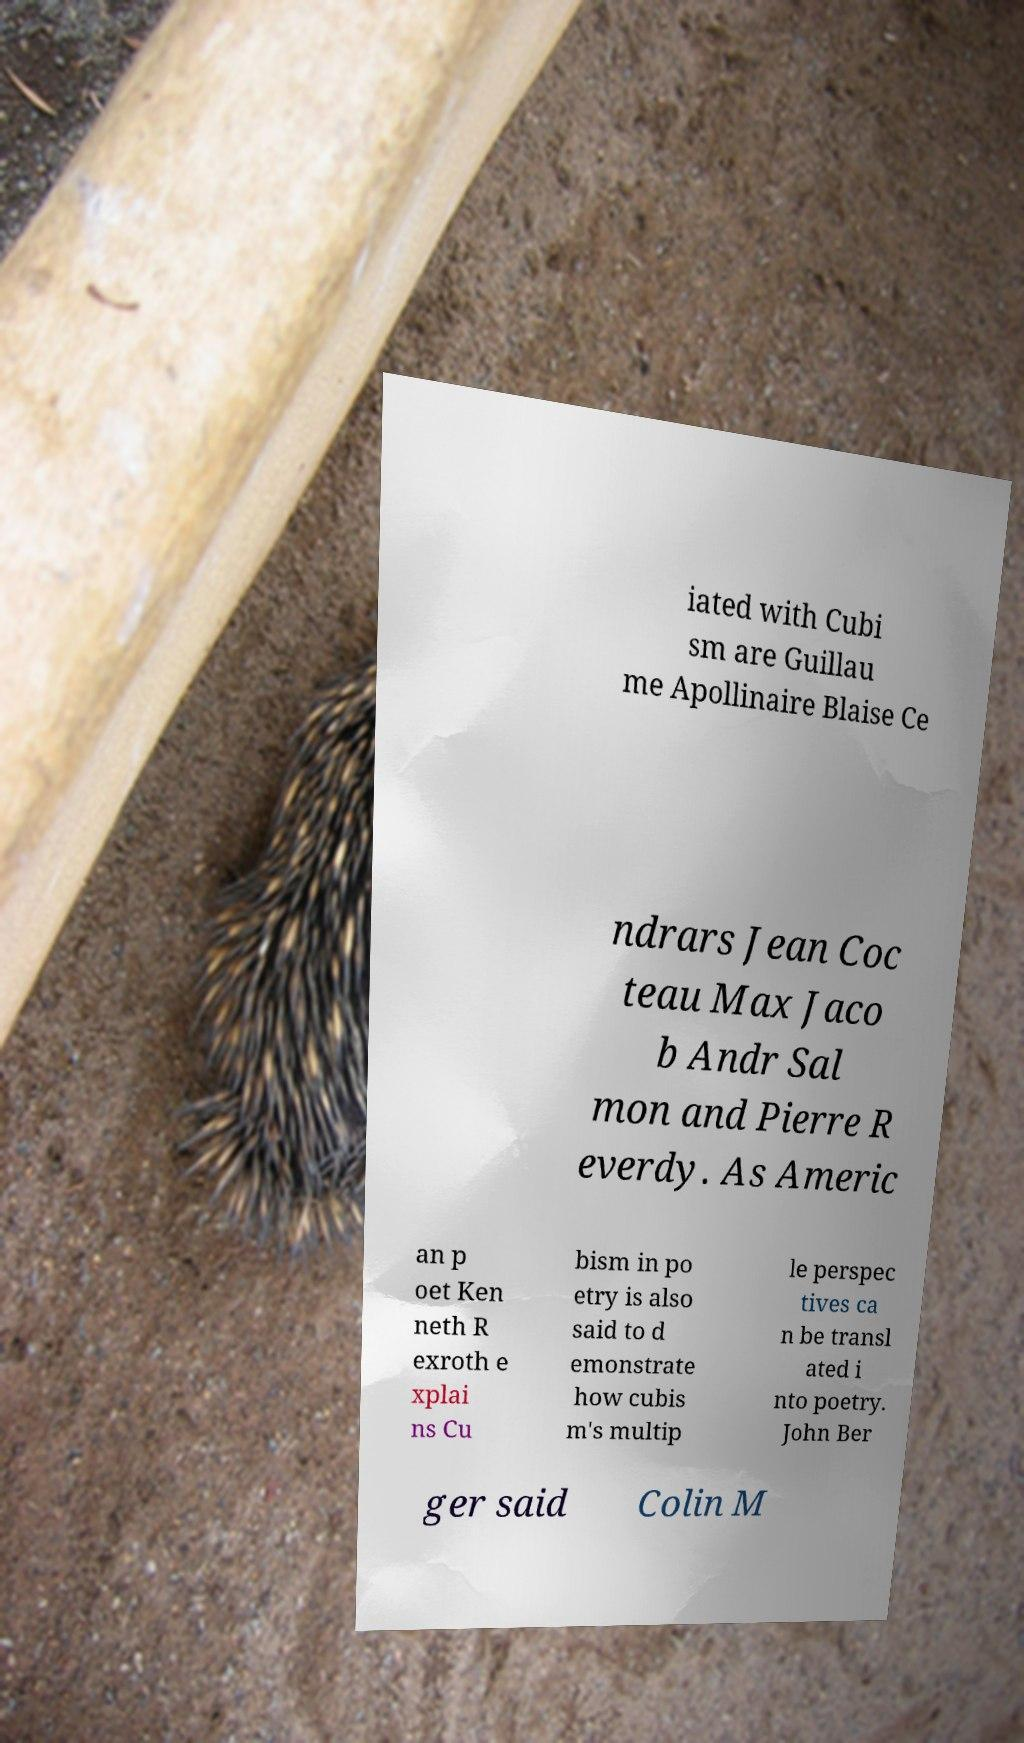For documentation purposes, I need the text within this image transcribed. Could you provide that? iated with Cubi sm are Guillau me Apollinaire Blaise Ce ndrars Jean Coc teau Max Jaco b Andr Sal mon and Pierre R everdy. As Americ an p oet Ken neth R exroth e xplai ns Cu bism in po etry is also said to d emonstrate how cubis m's multip le perspec tives ca n be transl ated i nto poetry. John Ber ger said Colin M 